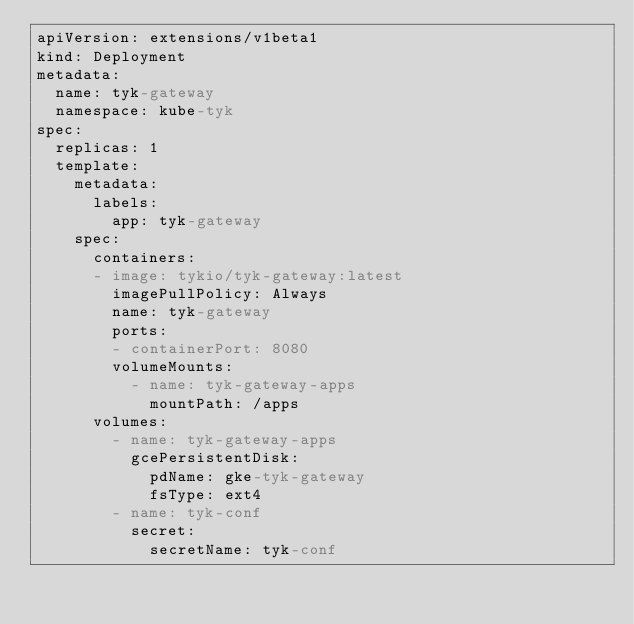Convert code to text. <code><loc_0><loc_0><loc_500><loc_500><_YAML_>apiVersion: extensions/v1beta1
kind: Deployment
metadata:
  name: tyk-gateway
  namespace: kube-tyk
spec:
  replicas: 1
  template:
    metadata:
      labels:
        app: tyk-gateway
    spec:
      containers:
      - image: tykio/tyk-gateway:latest
        imagePullPolicy: Always
        name: tyk-gateway
        ports:
        - containerPort: 8080
        volumeMounts:
          - name: tyk-gateway-apps
            mountPath: /apps
      volumes:
        - name: tyk-gateway-apps
          gcePersistentDisk:
            pdName: gke-tyk-gateway
            fsType: ext4
        - name: tyk-conf
          secret:
            secretName: tyk-conf</code> 